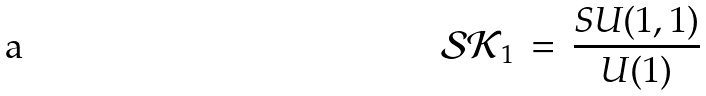<formula> <loc_0><loc_0><loc_500><loc_500>\mathcal { S K } _ { 1 } \, = \, \frac { S U ( 1 , 1 ) } { U ( 1 ) }</formula> 